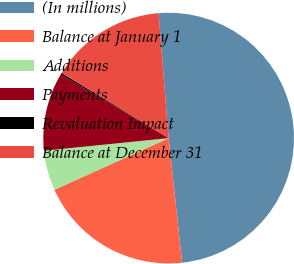Convert chart. <chart><loc_0><loc_0><loc_500><loc_500><pie_chart><fcel>(In millions)<fcel>Balance at January 1<fcel>Additions<fcel>Payments<fcel>Revaluation Impact<fcel>Balance at December 31<nl><fcel>49.56%<fcel>19.96%<fcel>5.15%<fcel>10.09%<fcel>0.22%<fcel>15.02%<nl></chart> 